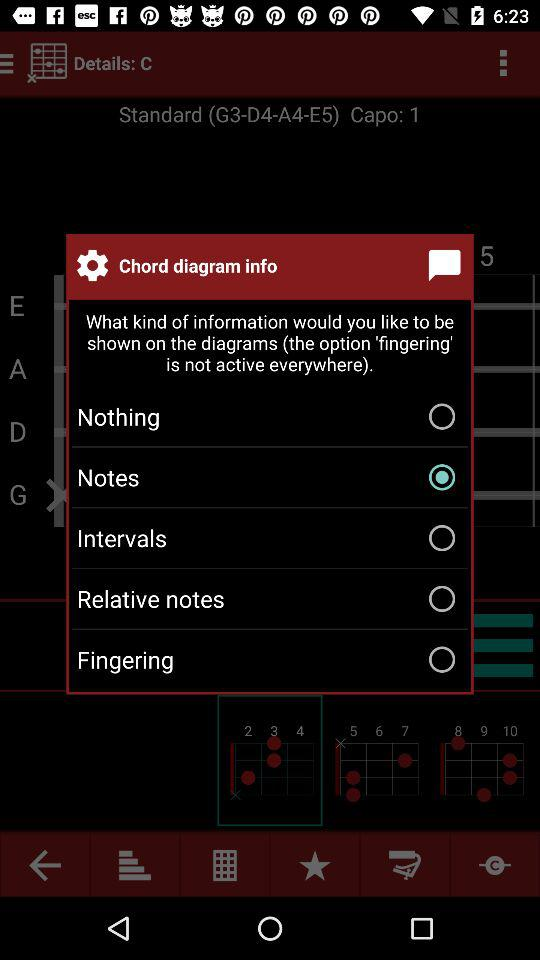How many favorites are there?
When the provided information is insufficient, respond with <no answer>. <no answer> 